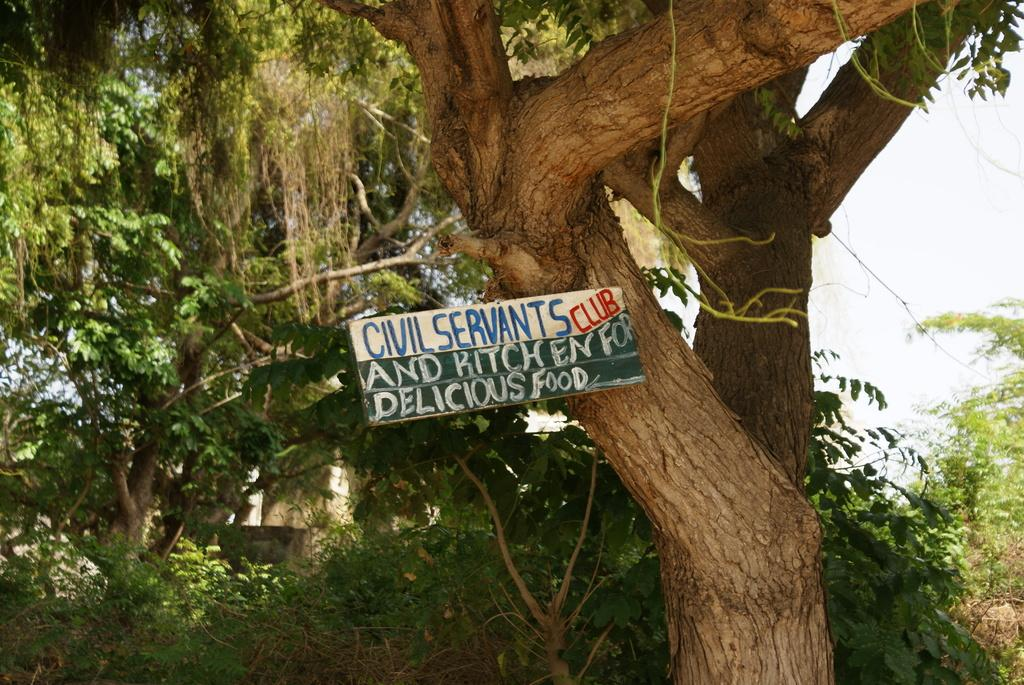What can be seen in the background of the image? The sky is visible in the image. What type of natural elements are present in the image? There are trees in the image. What is the board with information used for in the image? The board with information is likely used for displaying or sharing information. How many spies are hiding in the trees in the image? There are no spies present in the image; it only features trees and a board with information. 